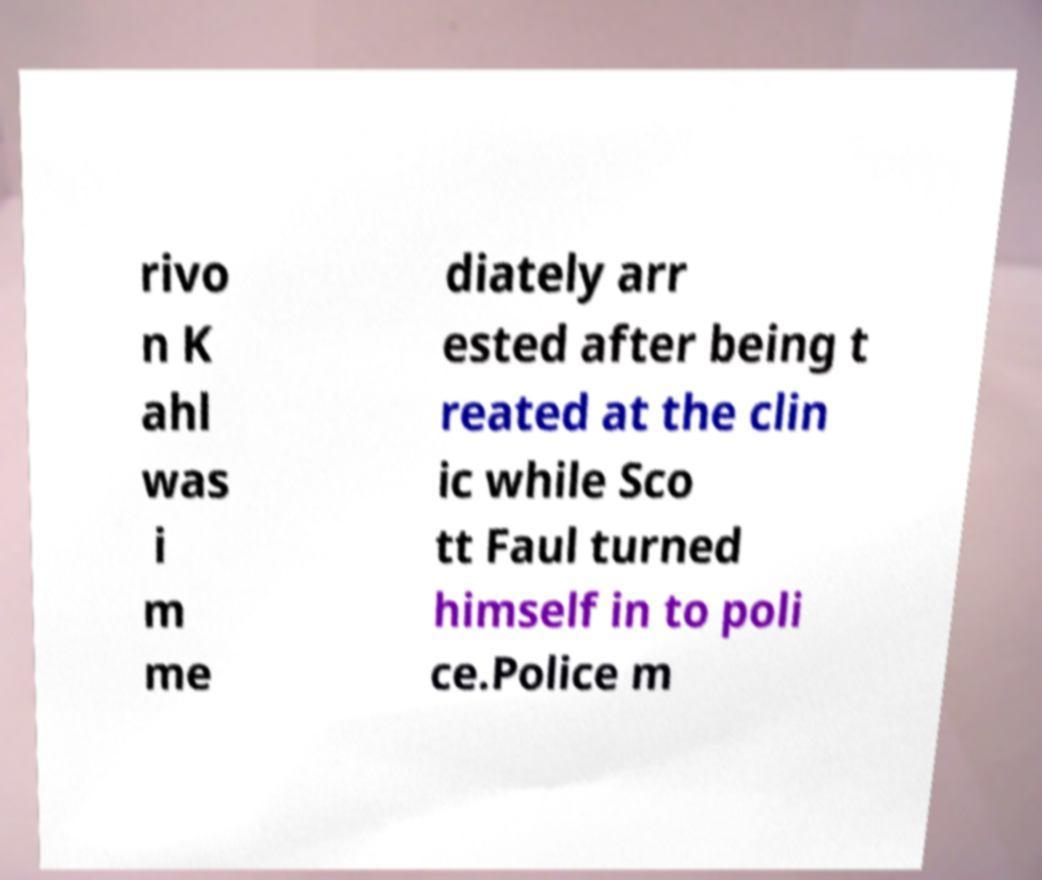Can you accurately transcribe the text from the provided image for me? rivo n K ahl was i m me diately arr ested after being t reated at the clin ic while Sco tt Faul turned himself in to poli ce.Police m 